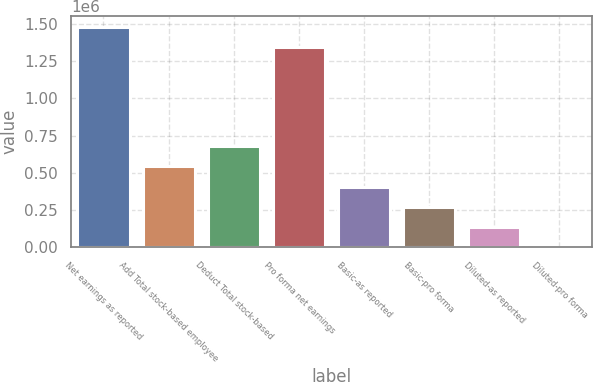<chart> <loc_0><loc_0><loc_500><loc_500><bar_chart><fcel>Net earnings as reported<fcel>Add Total stock-based employee<fcel>Deduct Total stock-based<fcel>Pro forma net earnings<fcel>Basic-as reported<fcel>Basic-pro forma<fcel>Diluted-as reported<fcel>Diluted-pro forma<nl><fcel>1.47776e+06<fcel>542067<fcel>677582<fcel>1.34224e+06<fcel>406552<fcel>271038<fcel>135523<fcel>8.16<nl></chart> 